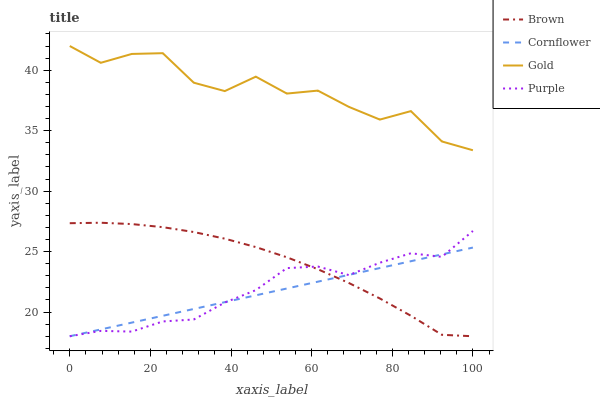Does Brown have the minimum area under the curve?
Answer yes or no. No. Does Brown have the maximum area under the curve?
Answer yes or no. No. Is Brown the smoothest?
Answer yes or no. No. Is Brown the roughest?
Answer yes or no. No. Does Gold have the lowest value?
Answer yes or no. No. Does Brown have the highest value?
Answer yes or no. No. Is Brown less than Gold?
Answer yes or no. Yes. Is Gold greater than Cornflower?
Answer yes or no. Yes. Does Brown intersect Gold?
Answer yes or no. No. 